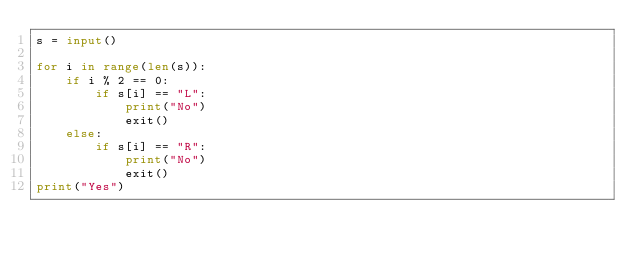<code> <loc_0><loc_0><loc_500><loc_500><_Python_>s = input()

for i in range(len(s)):
    if i % 2 == 0:
        if s[i] == "L":
            print("No")
            exit()
    else:
        if s[i] == "R":
            print("No")
            exit()
print("Yes")</code> 